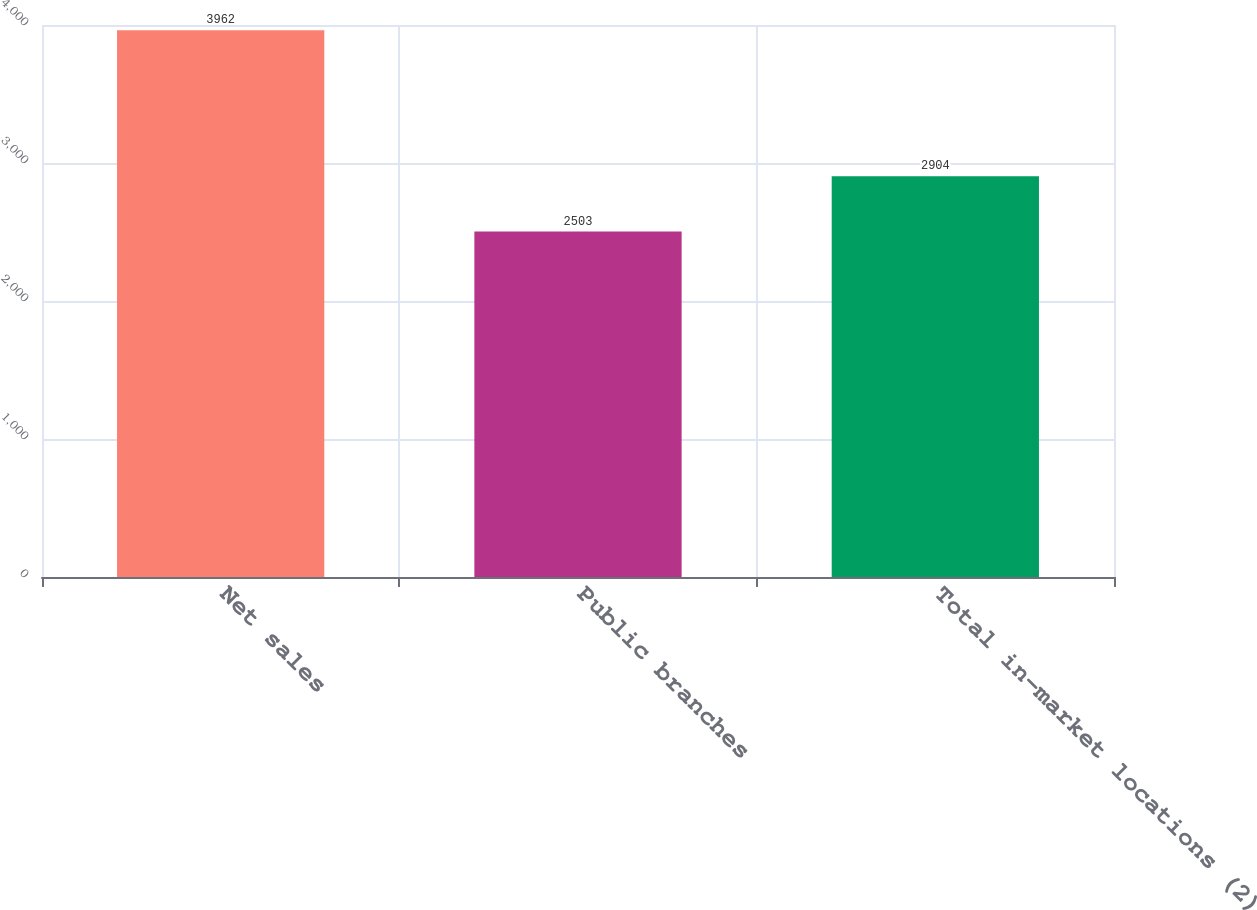<chart> <loc_0><loc_0><loc_500><loc_500><bar_chart><fcel>Net sales<fcel>Public branches<fcel>Total in-market locations (2)<nl><fcel>3962<fcel>2503<fcel>2904<nl></chart> 